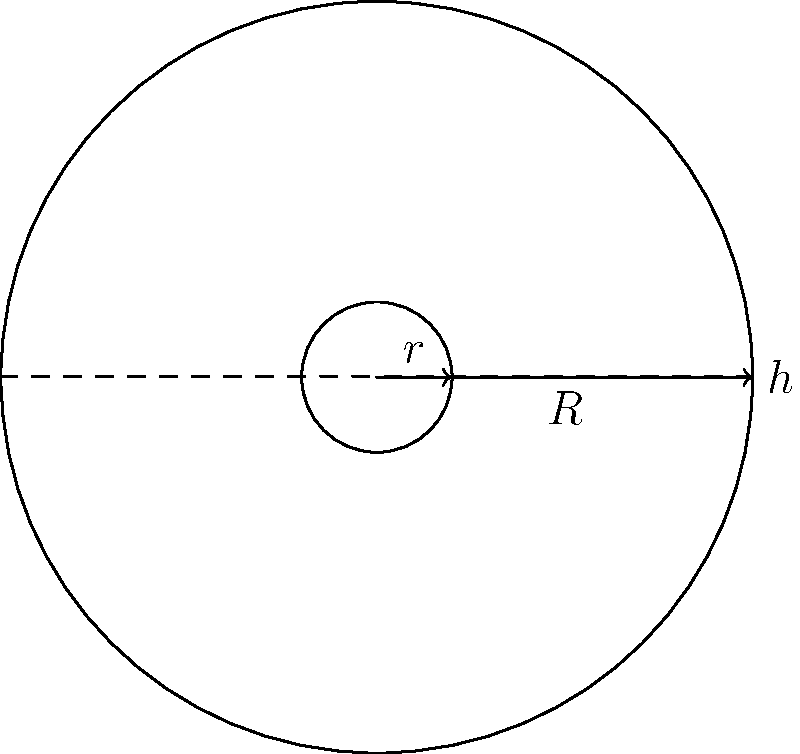As an avant-garde filmmaker, you're exploring unconventional film reel designs. You have a circular film reel with an outer radius $R = 5$ cm and an inner radius $r = 1$ cm. The film thickness is $h = 0.01$ cm. Assuming the film is tightly wound around the reel with no gaps, calculate the total length of the film in meters. Round your answer to the nearest meter. Let's approach this step-by-step:

1) The area of the film cross-section can be modeled as a rectangle. Its width is the difference between the outer and inner radii, and its height is the film thickness.

   Area of cross-section = $(R - r) \times h = (5 - 1) \times 0.01 = 0.04$ cm²

2) The volume of the film can be calculated by multiplying this area by the length of the film (L).

   Volume = $0.04L$ cm³

3) We can also calculate the volume by finding the difference between the volume of the outer cylinder and the inner cylinder:

   Volume = $\pi R^2 H - \pi r^2 H$, where H is the height of the cylinder

4) Equating these two volume expressions:

   $0.04L = \pi (5^2 - 1^2) H$

5) We know that $H = L / (2\pi R)$ because the film wraps around the circumference of the reel. Substituting this:

   $0.04L = \pi (25 - 1) \frac{L}{2\pi \times 5} = 24 \frac{L}{10} = 2.4L$

6) Simplifying:

   $0.04L = 2.4L$
   $L = 2.4L / 0.04 = 60$ m

7) Rounding to the nearest meter:

   $L \approx 60$ m
Answer: 60 m 